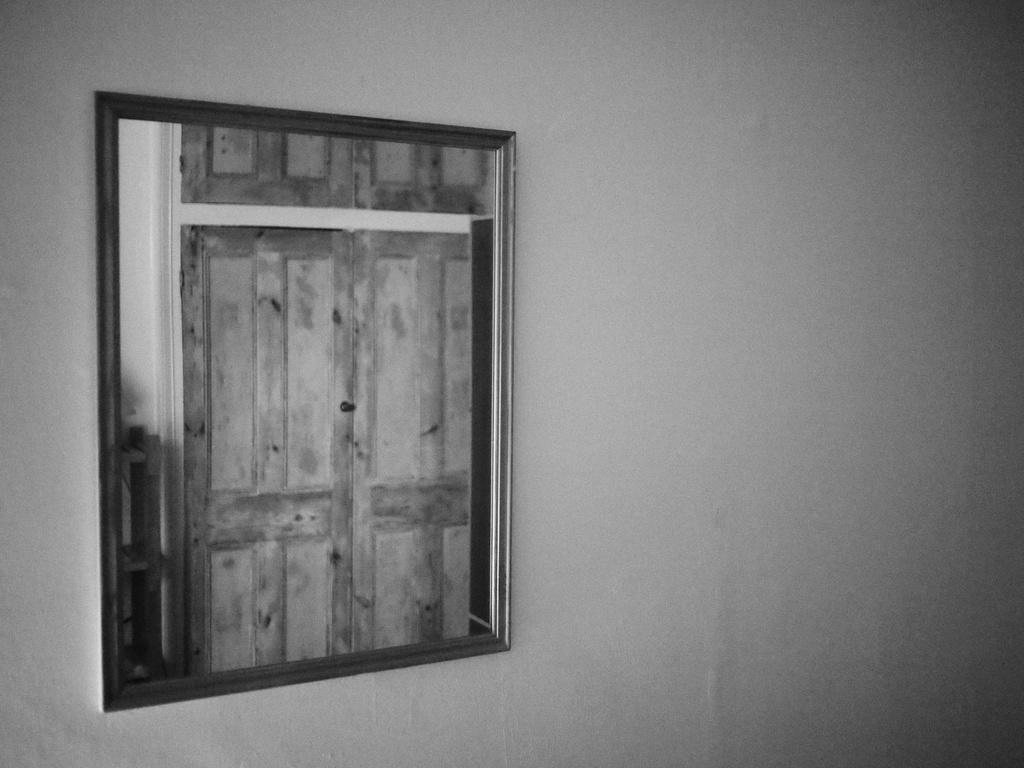What is the color scheme of the image? The image is black and white. What object can be seen in the image? There is a photo frame in the image. Where is the photo frame located? The photo frame is attached to a white wall. What is the manager's sense of humor in the image? There is no manager or sense of humor mentioned in the image; it only features a photo frame attached to a white wall. 